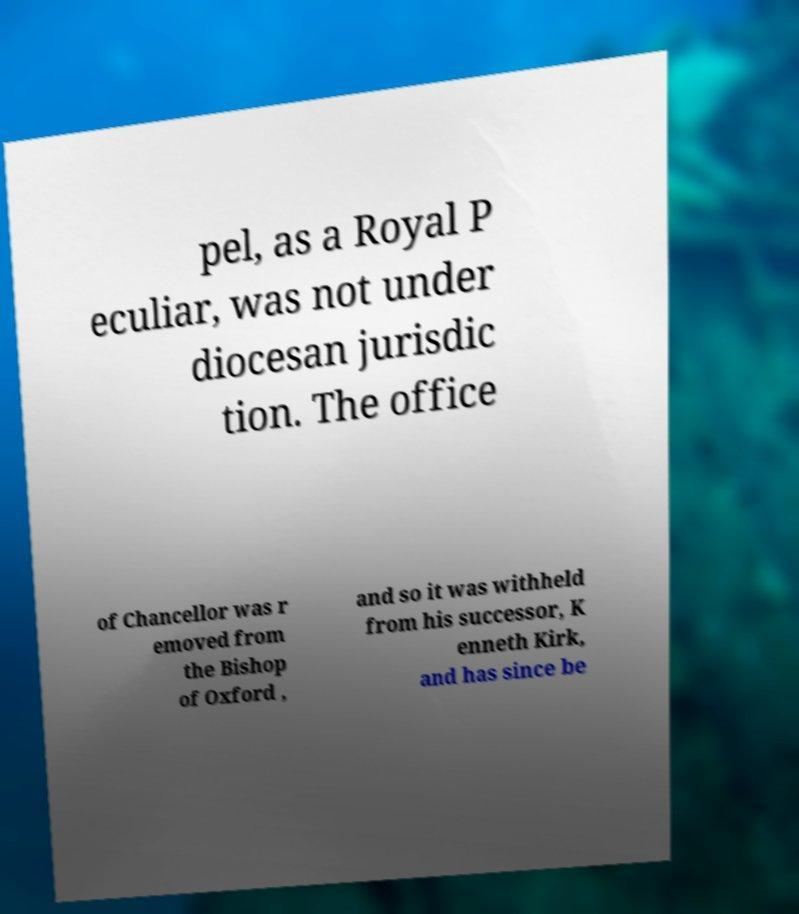There's text embedded in this image that I need extracted. Can you transcribe it verbatim? pel, as a Royal P eculiar, was not under diocesan jurisdic tion. The office of Chancellor was r emoved from the Bishop of Oxford , and so it was withheld from his successor, K enneth Kirk, and has since be 